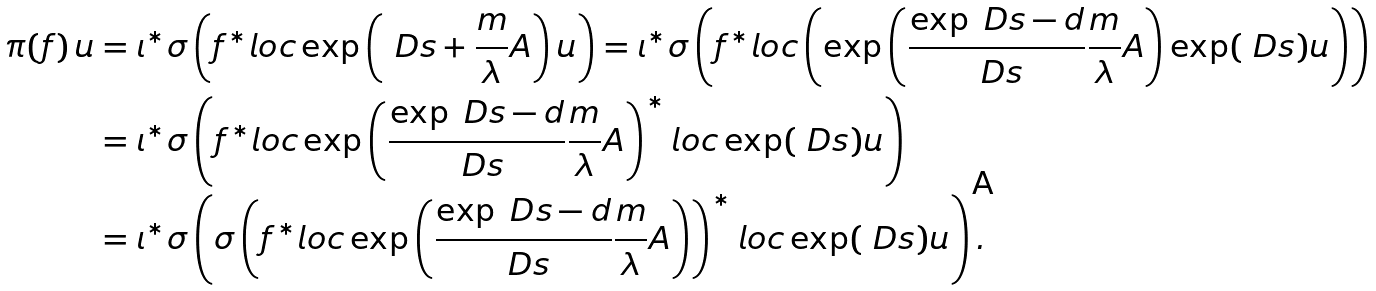Convert formula to latex. <formula><loc_0><loc_0><loc_500><loc_500>\pi ( f ) \, u & = \iota ^ { * } \sigma \left ( f ^ { * } l o c \exp \left ( \ D s + \frac { \i m } { \lambda } A \right ) u \right ) = \iota ^ { * } \sigma \left ( f ^ { * } l o c \left ( \exp \left ( \frac { \exp \ D s - \i d } { \ D s } \frac { \i m } { \lambda } A \right ) \exp ( \ D s ) u \right ) \right ) \\ & = \iota ^ { * } \sigma \left ( f ^ { * } l o c \exp \left ( \frac { \exp \ D s - \i d } { \ D s } \frac { \i m } { \lambda } A \right ) ^ { * } l o c \exp ( \ D s ) u \right ) \\ & = \iota ^ { * } \sigma \left ( \sigma \left ( f ^ { * } l o c \exp \left ( \frac { \exp \ D s - \i d } { \ D s } \frac { \i m } { \lambda } A \right ) \right ) ^ { * } l o c \exp ( \ D s ) u \right ) .</formula> 